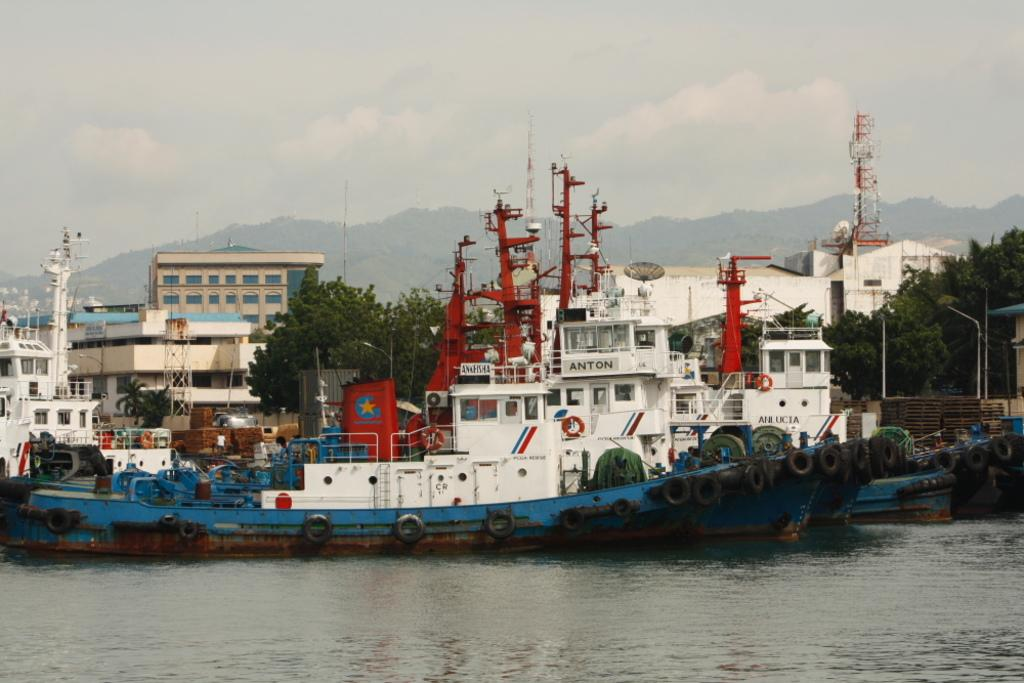What is the primary element in the image? There is water in the image. What is floating on the water? There are boats in the water. What are the unique features of these boats? The boats have tires and poles. What else can be seen on the boats? There are other unspecified objects on the boats. What can be seen in the background of the image? There are trees, buildings, hills, and the sky visible in the background of the image. Can you see a rat holding a balloon on one of the boats in the image? No, there is no rat or balloon present in the image. Is there a kettle boiling on any of the boats in the image? No, there is no kettle present in the image. 